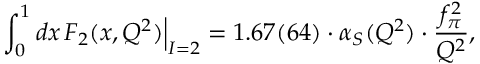<formula> <loc_0><loc_0><loc_500><loc_500>\int _ { 0 } ^ { 1 } d x \, F _ { 2 } ( x , Q ^ { 2 } ) \Big | _ { I = 2 } = 1 . 6 7 ( 6 4 ) \cdot \alpha _ { S } ( Q ^ { 2 } ) \cdot \frac { f _ { \pi } ^ { 2 } } { Q ^ { 2 } } ,</formula> 